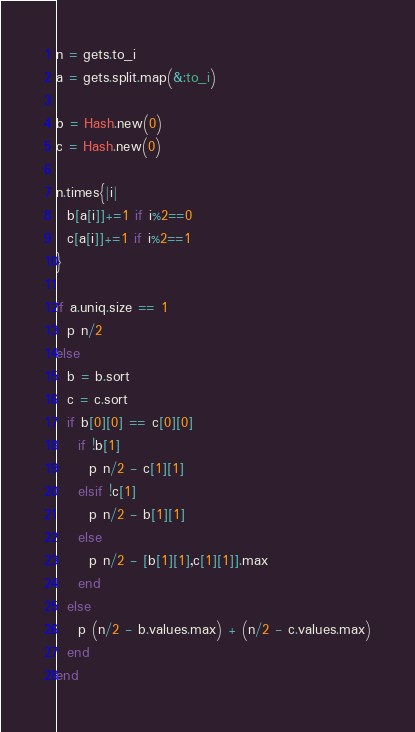Convert code to text. <code><loc_0><loc_0><loc_500><loc_500><_Ruby_>n = gets.to_i
a = gets.split.map(&:to_i)

b = Hash.new(0)
c = Hash.new(0)

n.times{|i|
  b[a[i]]+=1 if i%2==0
  c[a[i]]+=1 if i%2==1
}

if a.uniq.size == 1
  p n/2
else
  b = b.sort
  c = c.sort
  if b[0][0] == c[0][0]
    if !b[1]
      p n/2 - c[1][1]
    elsif !c[1]
      p n/2 - b[1][1]
    else
      p n/2 - [b[1][1],c[1][1]].max
    end
  else
    p (n/2 - b.values.max) + (n/2 - c.values.max)
  end
end
</code> 